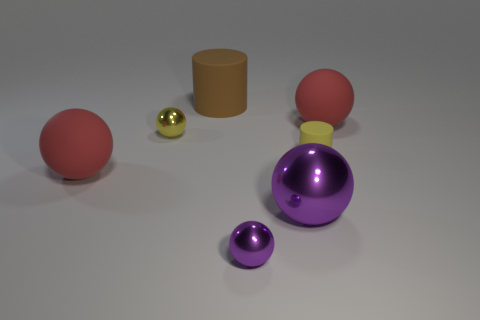What is the shape of the large brown rubber object?
Offer a terse response. Cylinder. Are there any tiny balls of the same color as the big shiny ball?
Your answer should be very brief. Yes. There is a metal thing behind the large purple metallic ball; is it the same color as the big cylinder?
Provide a succinct answer. No. What number of things are large red rubber balls that are on the left side of the big purple metallic ball or tiny gray matte things?
Your response must be concise. 1. Are there any big red rubber objects behind the large metal ball?
Offer a terse response. Yes. There is another object that is the same color as the large metallic object; what is it made of?
Keep it short and to the point. Metal. Do the big sphere to the left of the brown thing and the large brown thing have the same material?
Your response must be concise. Yes. There is a rubber cylinder that is on the left side of the cylinder that is to the right of the brown rubber thing; are there any brown objects in front of it?
Give a very brief answer. No. How many spheres are tiny yellow metallic things or small objects?
Ensure brevity in your answer.  2. There is a red thing that is in front of the small yellow matte cylinder; what is it made of?
Make the answer very short. Rubber. 